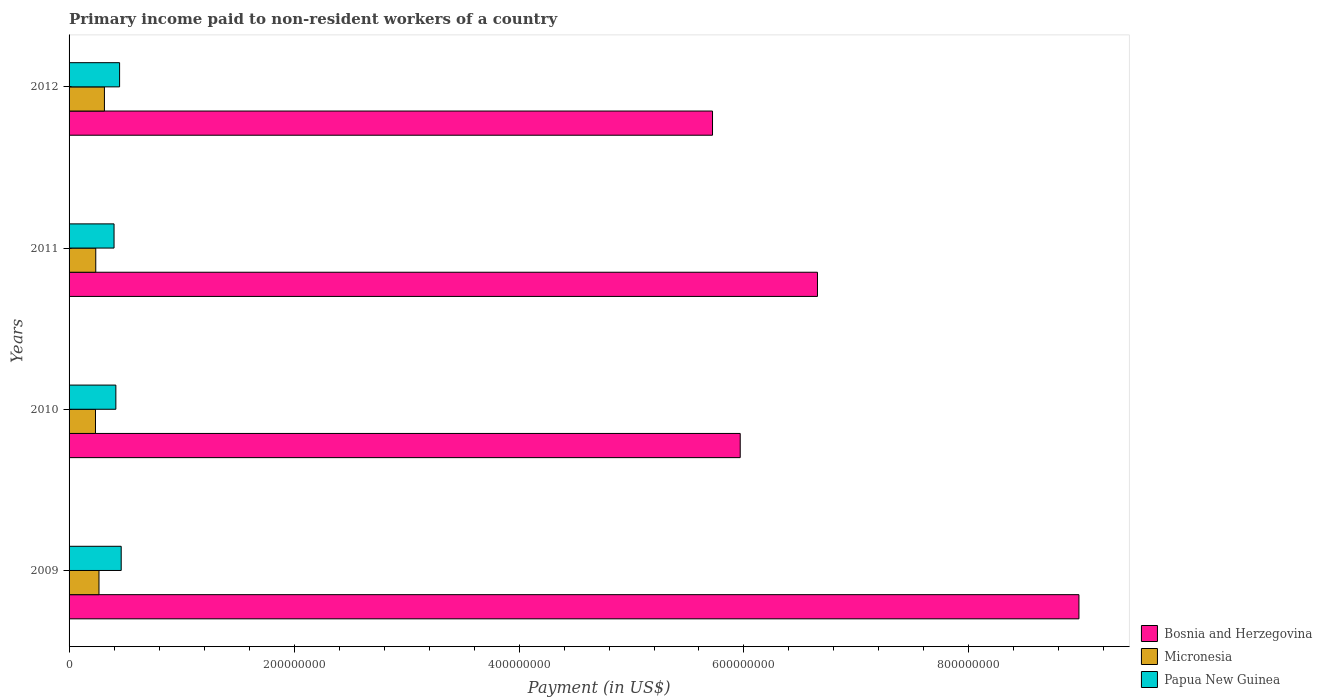How many different coloured bars are there?
Give a very brief answer. 3. How many groups of bars are there?
Provide a short and direct response. 4. How many bars are there on the 2nd tick from the top?
Make the answer very short. 3. In how many cases, is the number of bars for a given year not equal to the number of legend labels?
Make the answer very short. 0. What is the amount paid to workers in Micronesia in 2011?
Provide a succinct answer. 2.37e+07. Across all years, what is the maximum amount paid to workers in Bosnia and Herzegovina?
Provide a short and direct response. 8.98e+08. Across all years, what is the minimum amount paid to workers in Bosnia and Herzegovina?
Your answer should be compact. 5.72e+08. In which year was the amount paid to workers in Micronesia minimum?
Make the answer very short. 2010. What is the total amount paid to workers in Papua New Guinea in the graph?
Make the answer very short. 1.73e+08. What is the difference between the amount paid to workers in Bosnia and Herzegovina in 2009 and that in 2012?
Provide a short and direct response. 3.26e+08. What is the difference between the amount paid to workers in Micronesia in 2011 and the amount paid to workers in Bosnia and Herzegovina in 2012?
Give a very brief answer. -5.48e+08. What is the average amount paid to workers in Micronesia per year?
Ensure brevity in your answer.  2.63e+07. In the year 2012, what is the difference between the amount paid to workers in Bosnia and Herzegovina and amount paid to workers in Papua New Guinea?
Provide a short and direct response. 5.27e+08. In how many years, is the amount paid to workers in Bosnia and Herzegovina greater than 520000000 US$?
Give a very brief answer. 4. What is the ratio of the amount paid to workers in Bosnia and Herzegovina in 2011 to that in 2012?
Ensure brevity in your answer.  1.16. Is the amount paid to workers in Papua New Guinea in 2010 less than that in 2011?
Your response must be concise. No. Is the difference between the amount paid to workers in Bosnia and Herzegovina in 2010 and 2012 greater than the difference between the amount paid to workers in Papua New Guinea in 2010 and 2012?
Provide a succinct answer. Yes. What is the difference between the highest and the second highest amount paid to workers in Bosnia and Herzegovina?
Your response must be concise. 2.32e+08. What is the difference between the highest and the lowest amount paid to workers in Micronesia?
Your answer should be very brief. 7.94e+06. What does the 1st bar from the top in 2010 represents?
Ensure brevity in your answer.  Papua New Guinea. What does the 1st bar from the bottom in 2011 represents?
Provide a short and direct response. Bosnia and Herzegovina. How many bars are there?
Offer a terse response. 12. Are all the bars in the graph horizontal?
Your answer should be compact. Yes. Are the values on the major ticks of X-axis written in scientific E-notation?
Provide a succinct answer. No. Does the graph contain any zero values?
Give a very brief answer. No. Where does the legend appear in the graph?
Offer a terse response. Bottom right. What is the title of the graph?
Offer a terse response. Primary income paid to non-resident workers of a country. Does "Pakistan" appear as one of the legend labels in the graph?
Offer a terse response. No. What is the label or title of the X-axis?
Your answer should be compact. Payment (in US$). What is the label or title of the Y-axis?
Offer a very short reply. Years. What is the Payment (in US$) of Bosnia and Herzegovina in 2009?
Your response must be concise. 8.98e+08. What is the Payment (in US$) in Micronesia in 2009?
Your answer should be very brief. 2.66e+07. What is the Payment (in US$) of Papua New Guinea in 2009?
Provide a succinct answer. 4.63e+07. What is the Payment (in US$) of Bosnia and Herzegovina in 2010?
Offer a very short reply. 5.97e+08. What is the Payment (in US$) of Micronesia in 2010?
Offer a very short reply. 2.35e+07. What is the Payment (in US$) in Papua New Guinea in 2010?
Keep it short and to the point. 4.16e+07. What is the Payment (in US$) of Bosnia and Herzegovina in 2011?
Give a very brief answer. 6.65e+08. What is the Payment (in US$) of Micronesia in 2011?
Provide a short and direct response. 2.37e+07. What is the Payment (in US$) in Papua New Guinea in 2011?
Provide a succinct answer. 4.00e+07. What is the Payment (in US$) of Bosnia and Herzegovina in 2012?
Provide a short and direct response. 5.72e+08. What is the Payment (in US$) of Micronesia in 2012?
Provide a succinct answer. 3.14e+07. What is the Payment (in US$) of Papua New Guinea in 2012?
Your response must be concise. 4.49e+07. Across all years, what is the maximum Payment (in US$) of Bosnia and Herzegovina?
Provide a short and direct response. 8.98e+08. Across all years, what is the maximum Payment (in US$) of Micronesia?
Provide a succinct answer. 3.14e+07. Across all years, what is the maximum Payment (in US$) of Papua New Guinea?
Ensure brevity in your answer.  4.63e+07. Across all years, what is the minimum Payment (in US$) in Bosnia and Herzegovina?
Give a very brief answer. 5.72e+08. Across all years, what is the minimum Payment (in US$) in Micronesia?
Keep it short and to the point. 2.35e+07. Across all years, what is the minimum Payment (in US$) of Papua New Guinea?
Your answer should be compact. 4.00e+07. What is the total Payment (in US$) of Bosnia and Herzegovina in the graph?
Your answer should be very brief. 2.73e+09. What is the total Payment (in US$) of Micronesia in the graph?
Make the answer very short. 1.05e+08. What is the total Payment (in US$) in Papua New Guinea in the graph?
Keep it short and to the point. 1.73e+08. What is the difference between the Payment (in US$) of Bosnia and Herzegovina in 2009 and that in 2010?
Give a very brief answer. 3.01e+08. What is the difference between the Payment (in US$) of Micronesia in 2009 and that in 2010?
Provide a short and direct response. 3.11e+06. What is the difference between the Payment (in US$) of Papua New Guinea in 2009 and that in 2010?
Give a very brief answer. 4.76e+06. What is the difference between the Payment (in US$) of Bosnia and Herzegovina in 2009 and that in 2011?
Ensure brevity in your answer.  2.32e+08. What is the difference between the Payment (in US$) of Micronesia in 2009 and that in 2011?
Your answer should be very brief. 2.86e+06. What is the difference between the Payment (in US$) in Papua New Guinea in 2009 and that in 2011?
Provide a short and direct response. 6.37e+06. What is the difference between the Payment (in US$) in Bosnia and Herzegovina in 2009 and that in 2012?
Your response must be concise. 3.26e+08. What is the difference between the Payment (in US$) of Micronesia in 2009 and that in 2012?
Keep it short and to the point. -4.83e+06. What is the difference between the Payment (in US$) of Papua New Guinea in 2009 and that in 2012?
Provide a short and direct response. 1.43e+06. What is the difference between the Payment (in US$) of Bosnia and Herzegovina in 2010 and that in 2011?
Offer a terse response. -6.87e+07. What is the difference between the Payment (in US$) of Micronesia in 2010 and that in 2011?
Give a very brief answer. -2.48e+05. What is the difference between the Payment (in US$) of Papua New Guinea in 2010 and that in 2011?
Keep it short and to the point. 1.61e+06. What is the difference between the Payment (in US$) of Bosnia and Herzegovina in 2010 and that in 2012?
Offer a very short reply. 2.46e+07. What is the difference between the Payment (in US$) in Micronesia in 2010 and that in 2012?
Your answer should be very brief. -7.94e+06. What is the difference between the Payment (in US$) in Papua New Guinea in 2010 and that in 2012?
Make the answer very short. -3.33e+06. What is the difference between the Payment (in US$) in Bosnia and Herzegovina in 2011 and that in 2012?
Your response must be concise. 9.33e+07. What is the difference between the Payment (in US$) in Micronesia in 2011 and that in 2012?
Your answer should be compact. -7.70e+06. What is the difference between the Payment (in US$) in Papua New Guinea in 2011 and that in 2012?
Make the answer very short. -4.94e+06. What is the difference between the Payment (in US$) in Bosnia and Herzegovina in 2009 and the Payment (in US$) in Micronesia in 2010?
Make the answer very short. 8.74e+08. What is the difference between the Payment (in US$) of Bosnia and Herzegovina in 2009 and the Payment (in US$) of Papua New Guinea in 2010?
Provide a succinct answer. 8.56e+08. What is the difference between the Payment (in US$) in Micronesia in 2009 and the Payment (in US$) in Papua New Guinea in 2010?
Make the answer very short. -1.50e+07. What is the difference between the Payment (in US$) in Bosnia and Herzegovina in 2009 and the Payment (in US$) in Micronesia in 2011?
Provide a succinct answer. 8.74e+08. What is the difference between the Payment (in US$) of Bosnia and Herzegovina in 2009 and the Payment (in US$) of Papua New Guinea in 2011?
Provide a short and direct response. 8.58e+08. What is the difference between the Payment (in US$) of Micronesia in 2009 and the Payment (in US$) of Papua New Guinea in 2011?
Provide a succinct answer. -1.34e+07. What is the difference between the Payment (in US$) in Bosnia and Herzegovina in 2009 and the Payment (in US$) in Micronesia in 2012?
Ensure brevity in your answer.  8.66e+08. What is the difference between the Payment (in US$) of Bosnia and Herzegovina in 2009 and the Payment (in US$) of Papua New Guinea in 2012?
Your response must be concise. 8.53e+08. What is the difference between the Payment (in US$) in Micronesia in 2009 and the Payment (in US$) in Papua New Guinea in 2012?
Provide a short and direct response. -1.83e+07. What is the difference between the Payment (in US$) in Bosnia and Herzegovina in 2010 and the Payment (in US$) in Micronesia in 2011?
Your answer should be compact. 5.73e+08. What is the difference between the Payment (in US$) of Bosnia and Herzegovina in 2010 and the Payment (in US$) of Papua New Guinea in 2011?
Offer a terse response. 5.57e+08. What is the difference between the Payment (in US$) in Micronesia in 2010 and the Payment (in US$) in Papua New Guinea in 2011?
Keep it short and to the point. -1.65e+07. What is the difference between the Payment (in US$) of Bosnia and Herzegovina in 2010 and the Payment (in US$) of Micronesia in 2012?
Give a very brief answer. 5.65e+08. What is the difference between the Payment (in US$) of Bosnia and Herzegovina in 2010 and the Payment (in US$) of Papua New Guinea in 2012?
Your answer should be very brief. 5.52e+08. What is the difference between the Payment (in US$) in Micronesia in 2010 and the Payment (in US$) in Papua New Guinea in 2012?
Ensure brevity in your answer.  -2.14e+07. What is the difference between the Payment (in US$) in Bosnia and Herzegovina in 2011 and the Payment (in US$) in Micronesia in 2012?
Your answer should be compact. 6.34e+08. What is the difference between the Payment (in US$) of Bosnia and Herzegovina in 2011 and the Payment (in US$) of Papua New Guinea in 2012?
Provide a short and direct response. 6.20e+08. What is the difference between the Payment (in US$) of Micronesia in 2011 and the Payment (in US$) of Papua New Guinea in 2012?
Ensure brevity in your answer.  -2.12e+07. What is the average Payment (in US$) of Bosnia and Herzegovina per year?
Provide a short and direct response. 6.83e+08. What is the average Payment (in US$) in Micronesia per year?
Your answer should be very brief. 2.63e+07. What is the average Payment (in US$) in Papua New Guinea per year?
Offer a terse response. 4.32e+07. In the year 2009, what is the difference between the Payment (in US$) of Bosnia and Herzegovina and Payment (in US$) of Micronesia?
Make the answer very short. 8.71e+08. In the year 2009, what is the difference between the Payment (in US$) in Bosnia and Herzegovina and Payment (in US$) in Papua New Guinea?
Ensure brevity in your answer.  8.51e+08. In the year 2009, what is the difference between the Payment (in US$) of Micronesia and Payment (in US$) of Papua New Guinea?
Your answer should be very brief. -1.98e+07. In the year 2010, what is the difference between the Payment (in US$) in Bosnia and Herzegovina and Payment (in US$) in Micronesia?
Offer a very short reply. 5.73e+08. In the year 2010, what is the difference between the Payment (in US$) of Bosnia and Herzegovina and Payment (in US$) of Papua New Guinea?
Your answer should be compact. 5.55e+08. In the year 2010, what is the difference between the Payment (in US$) of Micronesia and Payment (in US$) of Papua New Guinea?
Your answer should be very brief. -1.81e+07. In the year 2011, what is the difference between the Payment (in US$) of Bosnia and Herzegovina and Payment (in US$) of Micronesia?
Your answer should be very brief. 6.42e+08. In the year 2011, what is the difference between the Payment (in US$) of Bosnia and Herzegovina and Payment (in US$) of Papua New Guinea?
Your answer should be very brief. 6.25e+08. In the year 2011, what is the difference between the Payment (in US$) of Micronesia and Payment (in US$) of Papua New Guinea?
Provide a succinct answer. -1.62e+07. In the year 2012, what is the difference between the Payment (in US$) of Bosnia and Herzegovina and Payment (in US$) of Micronesia?
Offer a very short reply. 5.41e+08. In the year 2012, what is the difference between the Payment (in US$) in Bosnia and Herzegovina and Payment (in US$) in Papua New Guinea?
Offer a very short reply. 5.27e+08. In the year 2012, what is the difference between the Payment (in US$) of Micronesia and Payment (in US$) of Papua New Guinea?
Make the answer very short. -1.35e+07. What is the ratio of the Payment (in US$) of Bosnia and Herzegovina in 2009 to that in 2010?
Give a very brief answer. 1.5. What is the ratio of the Payment (in US$) of Micronesia in 2009 to that in 2010?
Provide a short and direct response. 1.13. What is the ratio of the Payment (in US$) in Papua New Guinea in 2009 to that in 2010?
Your answer should be very brief. 1.11. What is the ratio of the Payment (in US$) of Bosnia and Herzegovina in 2009 to that in 2011?
Offer a very short reply. 1.35. What is the ratio of the Payment (in US$) of Micronesia in 2009 to that in 2011?
Offer a very short reply. 1.12. What is the ratio of the Payment (in US$) in Papua New Guinea in 2009 to that in 2011?
Your answer should be very brief. 1.16. What is the ratio of the Payment (in US$) in Bosnia and Herzegovina in 2009 to that in 2012?
Give a very brief answer. 1.57. What is the ratio of the Payment (in US$) in Micronesia in 2009 to that in 2012?
Your answer should be compact. 0.85. What is the ratio of the Payment (in US$) of Papua New Guinea in 2009 to that in 2012?
Offer a very short reply. 1.03. What is the ratio of the Payment (in US$) of Bosnia and Herzegovina in 2010 to that in 2011?
Give a very brief answer. 0.9. What is the ratio of the Payment (in US$) in Micronesia in 2010 to that in 2011?
Your answer should be very brief. 0.99. What is the ratio of the Payment (in US$) in Papua New Guinea in 2010 to that in 2011?
Make the answer very short. 1.04. What is the ratio of the Payment (in US$) in Bosnia and Herzegovina in 2010 to that in 2012?
Keep it short and to the point. 1.04. What is the ratio of the Payment (in US$) in Micronesia in 2010 to that in 2012?
Give a very brief answer. 0.75. What is the ratio of the Payment (in US$) in Papua New Guinea in 2010 to that in 2012?
Your answer should be compact. 0.93. What is the ratio of the Payment (in US$) of Bosnia and Herzegovina in 2011 to that in 2012?
Your response must be concise. 1.16. What is the ratio of the Payment (in US$) in Micronesia in 2011 to that in 2012?
Make the answer very short. 0.76. What is the ratio of the Payment (in US$) in Papua New Guinea in 2011 to that in 2012?
Ensure brevity in your answer.  0.89. What is the difference between the highest and the second highest Payment (in US$) of Bosnia and Herzegovina?
Your answer should be very brief. 2.32e+08. What is the difference between the highest and the second highest Payment (in US$) of Micronesia?
Provide a short and direct response. 4.83e+06. What is the difference between the highest and the second highest Payment (in US$) of Papua New Guinea?
Provide a short and direct response. 1.43e+06. What is the difference between the highest and the lowest Payment (in US$) in Bosnia and Herzegovina?
Your answer should be very brief. 3.26e+08. What is the difference between the highest and the lowest Payment (in US$) in Micronesia?
Make the answer very short. 7.94e+06. What is the difference between the highest and the lowest Payment (in US$) in Papua New Guinea?
Give a very brief answer. 6.37e+06. 